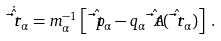Convert formula to latex. <formula><loc_0><loc_0><loc_500><loc_500>\dot { \hat { \vec { t } { r } } } _ { \alpha } = m _ { \alpha } ^ { - 1 } \left [ \hat { \vec { t } { p } } _ { \alpha } - q _ { \alpha } \hat { \vec { t } { A } } ( \hat { \vec { t } { r } } _ { \alpha } ) \right ] \, .</formula> 